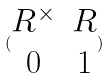Convert formula to latex. <formula><loc_0><loc_0><loc_500><loc_500>( \begin{matrix} R ^ { \times } & R \\ 0 & 1 \end{matrix} )</formula> 